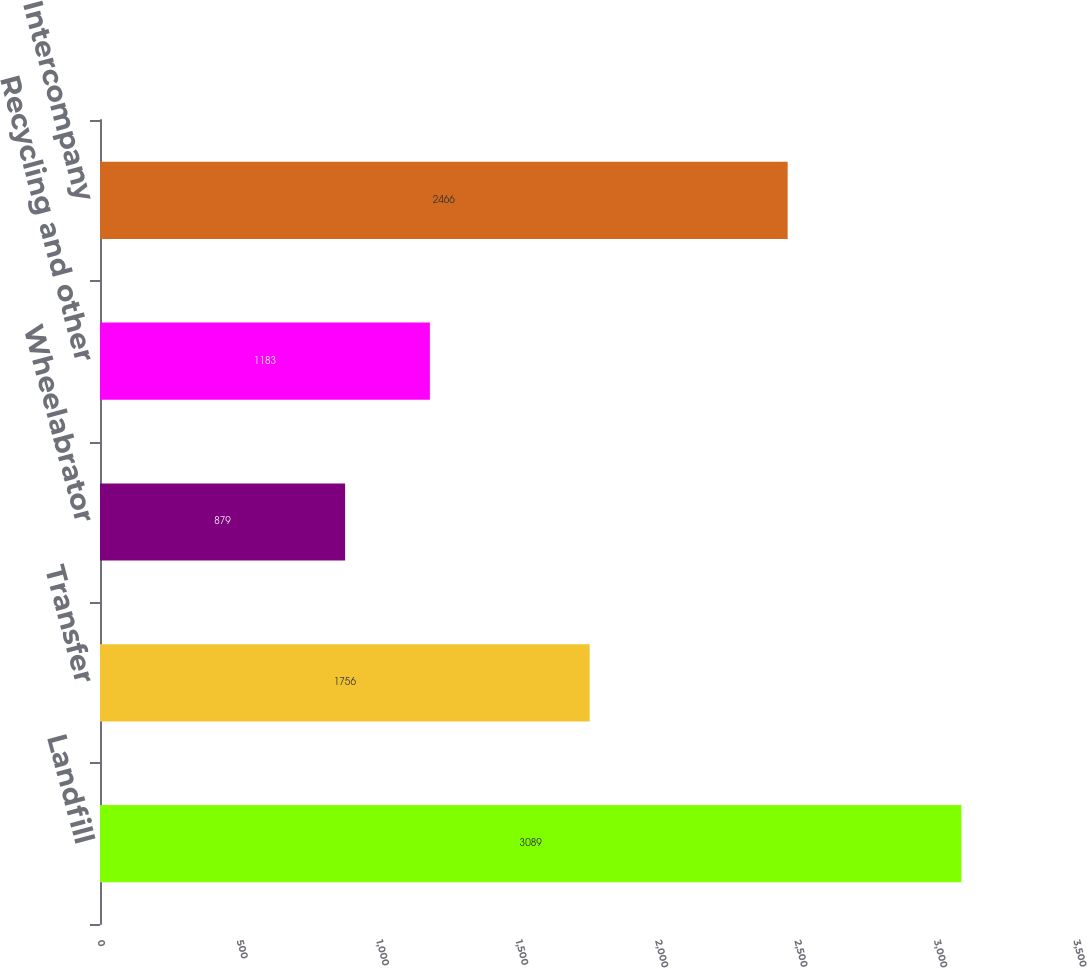Convert chart. <chart><loc_0><loc_0><loc_500><loc_500><bar_chart><fcel>Landfill<fcel>Transfer<fcel>Wheelabrator<fcel>Recycling and other<fcel>Intercompany<nl><fcel>3089<fcel>1756<fcel>879<fcel>1183<fcel>2466<nl></chart> 